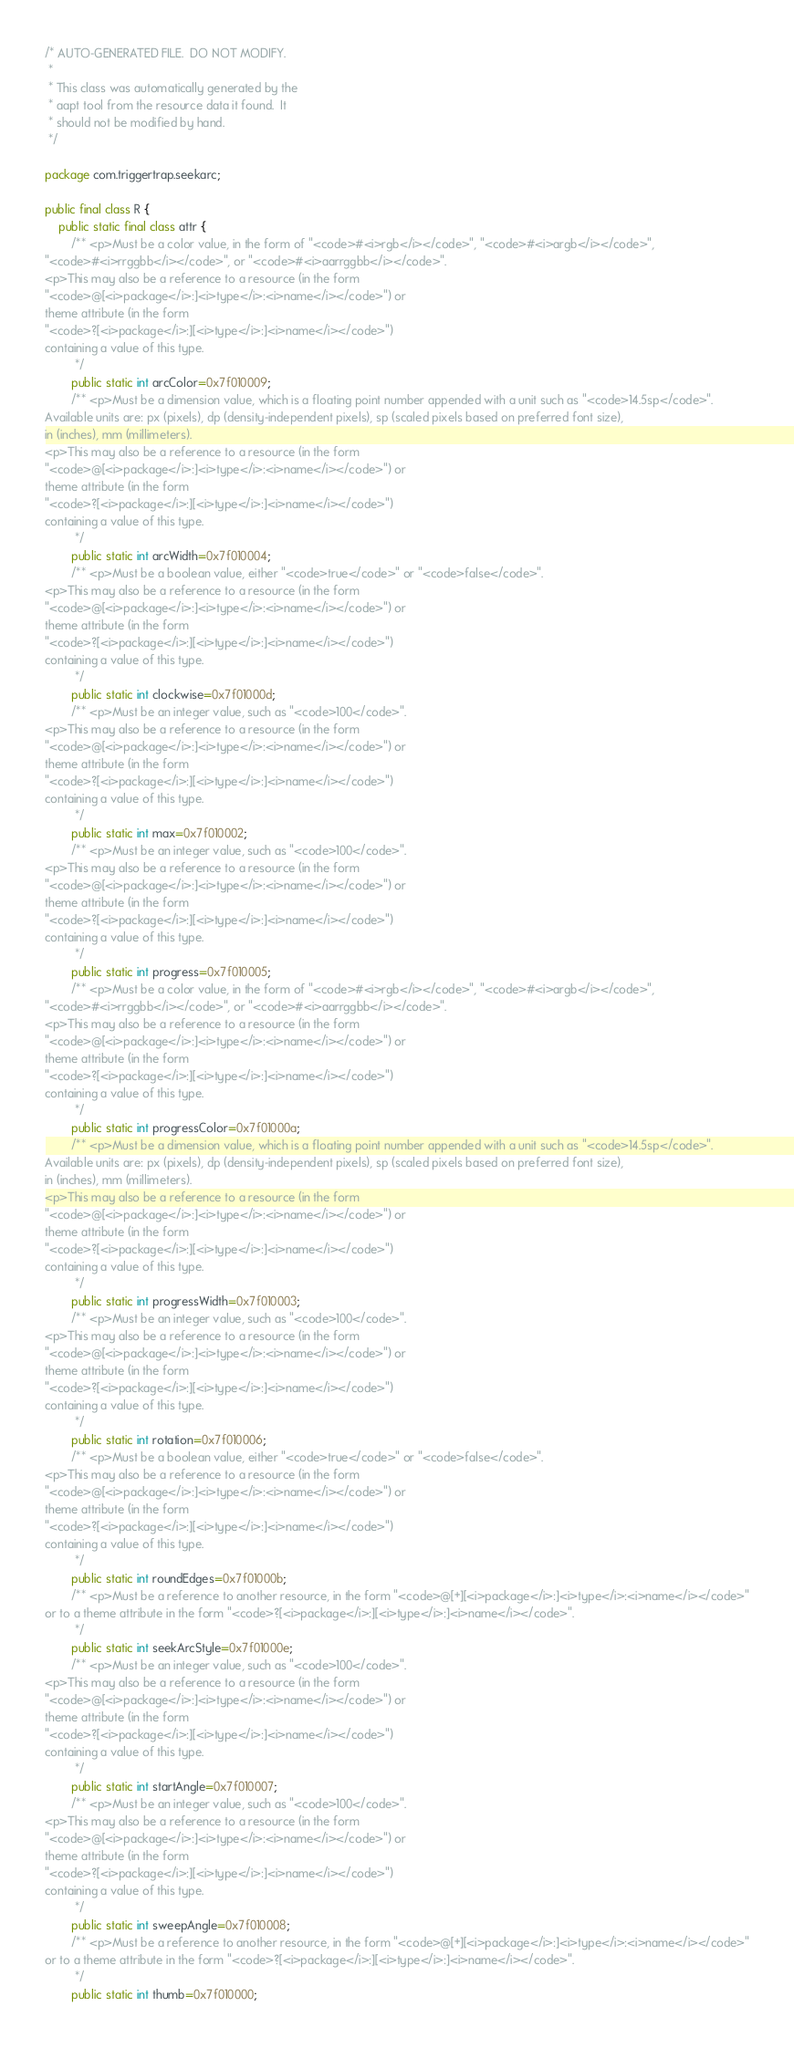<code> <loc_0><loc_0><loc_500><loc_500><_Java_>/* AUTO-GENERATED FILE.  DO NOT MODIFY.
 *
 * This class was automatically generated by the
 * aapt tool from the resource data it found.  It
 * should not be modified by hand.
 */

package com.triggertrap.seekarc;

public final class R {
    public static final class attr {
        /** <p>Must be a color value, in the form of "<code>#<i>rgb</i></code>", "<code>#<i>argb</i></code>",
"<code>#<i>rrggbb</i></code>", or "<code>#<i>aarrggbb</i></code>".
<p>This may also be a reference to a resource (in the form
"<code>@[<i>package</i>:]<i>type</i>:<i>name</i></code>") or
theme attribute (in the form
"<code>?[<i>package</i>:][<i>type</i>:]<i>name</i></code>")
containing a value of this type.
         */
        public static int arcColor=0x7f010009;
        /** <p>Must be a dimension value, which is a floating point number appended with a unit such as "<code>14.5sp</code>".
Available units are: px (pixels), dp (density-independent pixels), sp (scaled pixels based on preferred font size),
in (inches), mm (millimeters).
<p>This may also be a reference to a resource (in the form
"<code>@[<i>package</i>:]<i>type</i>:<i>name</i></code>") or
theme attribute (in the form
"<code>?[<i>package</i>:][<i>type</i>:]<i>name</i></code>")
containing a value of this type.
         */
        public static int arcWidth=0x7f010004;
        /** <p>Must be a boolean value, either "<code>true</code>" or "<code>false</code>".
<p>This may also be a reference to a resource (in the form
"<code>@[<i>package</i>:]<i>type</i>:<i>name</i></code>") or
theme attribute (in the form
"<code>?[<i>package</i>:][<i>type</i>:]<i>name</i></code>")
containing a value of this type.
         */
        public static int clockwise=0x7f01000d;
        /** <p>Must be an integer value, such as "<code>100</code>".
<p>This may also be a reference to a resource (in the form
"<code>@[<i>package</i>:]<i>type</i>:<i>name</i></code>") or
theme attribute (in the form
"<code>?[<i>package</i>:][<i>type</i>:]<i>name</i></code>")
containing a value of this type.
         */
        public static int max=0x7f010002;
        /** <p>Must be an integer value, such as "<code>100</code>".
<p>This may also be a reference to a resource (in the form
"<code>@[<i>package</i>:]<i>type</i>:<i>name</i></code>") or
theme attribute (in the form
"<code>?[<i>package</i>:][<i>type</i>:]<i>name</i></code>")
containing a value of this type.
         */
        public static int progress=0x7f010005;
        /** <p>Must be a color value, in the form of "<code>#<i>rgb</i></code>", "<code>#<i>argb</i></code>",
"<code>#<i>rrggbb</i></code>", or "<code>#<i>aarrggbb</i></code>".
<p>This may also be a reference to a resource (in the form
"<code>@[<i>package</i>:]<i>type</i>:<i>name</i></code>") or
theme attribute (in the form
"<code>?[<i>package</i>:][<i>type</i>:]<i>name</i></code>")
containing a value of this type.
         */
        public static int progressColor=0x7f01000a;
        /** <p>Must be a dimension value, which is a floating point number appended with a unit such as "<code>14.5sp</code>".
Available units are: px (pixels), dp (density-independent pixels), sp (scaled pixels based on preferred font size),
in (inches), mm (millimeters).
<p>This may also be a reference to a resource (in the form
"<code>@[<i>package</i>:]<i>type</i>:<i>name</i></code>") or
theme attribute (in the form
"<code>?[<i>package</i>:][<i>type</i>:]<i>name</i></code>")
containing a value of this type.
         */
        public static int progressWidth=0x7f010003;
        /** <p>Must be an integer value, such as "<code>100</code>".
<p>This may also be a reference to a resource (in the form
"<code>@[<i>package</i>:]<i>type</i>:<i>name</i></code>") or
theme attribute (in the form
"<code>?[<i>package</i>:][<i>type</i>:]<i>name</i></code>")
containing a value of this type.
         */
        public static int rotation=0x7f010006;
        /** <p>Must be a boolean value, either "<code>true</code>" or "<code>false</code>".
<p>This may also be a reference to a resource (in the form
"<code>@[<i>package</i>:]<i>type</i>:<i>name</i></code>") or
theme attribute (in the form
"<code>?[<i>package</i>:][<i>type</i>:]<i>name</i></code>")
containing a value of this type.
         */
        public static int roundEdges=0x7f01000b;
        /** <p>Must be a reference to another resource, in the form "<code>@[+][<i>package</i>:]<i>type</i>:<i>name</i></code>"
or to a theme attribute in the form "<code>?[<i>package</i>:][<i>type</i>:]<i>name</i></code>".
         */
        public static int seekArcStyle=0x7f01000e;
        /** <p>Must be an integer value, such as "<code>100</code>".
<p>This may also be a reference to a resource (in the form
"<code>@[<i>package</i>:]<i>type</i>:<i>name</i></code>") or
theme attribute (in the form
"<code>?[<i>package</i>:][<i>type</i>:]<i>name</i></code>")
containing a value of this type.
         */
        public static int startAngle=0x7f010007;
        /** <p>Must be an integer value, such as "<code>100</code>".
<p>This may also be a reference to a resource (in the form
"<code>@[<i>package</i>:]<i>type</i>:<i>name</i></code>") or
theme attribute (in the form
"<code>?[<i>package</i>:][<i>type</i>:]<i>name</i></code>")
containing a value of this type.
         */
        public static int sweepAngle=0x7f010008;
        /** <p>Must be a reference to another resource, in the form "<code>@[+][<i>package</i>:]<i>type</i>:<i>name</i></code>"
or to a theme attribute in the form "<code>?[<i>package</i>:][<i>type</i>:]<i>name</i></code>".
         */
        public static int thumb=0x7f010000;</code> 